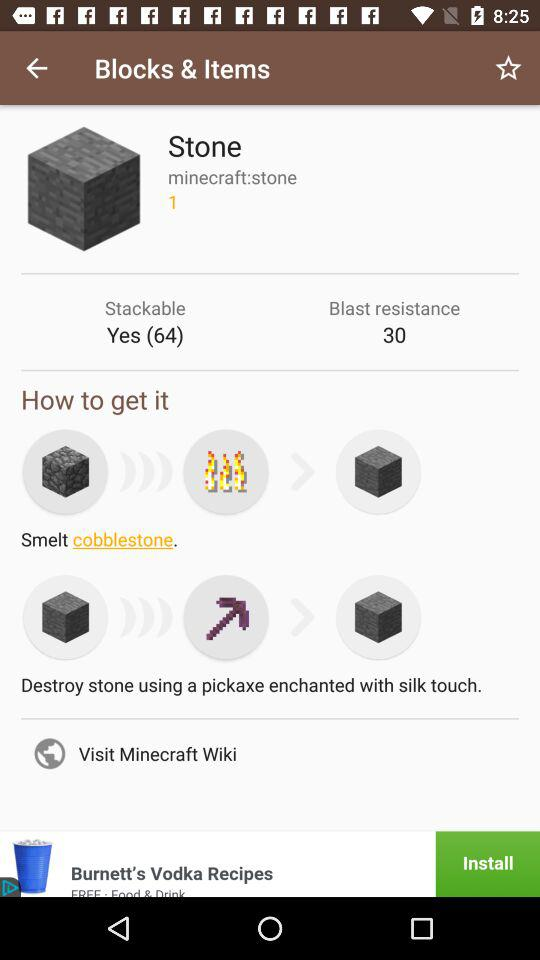What is the number of "Stone" that can be stacked? The number of "Stone" that can be stacked is 64. 